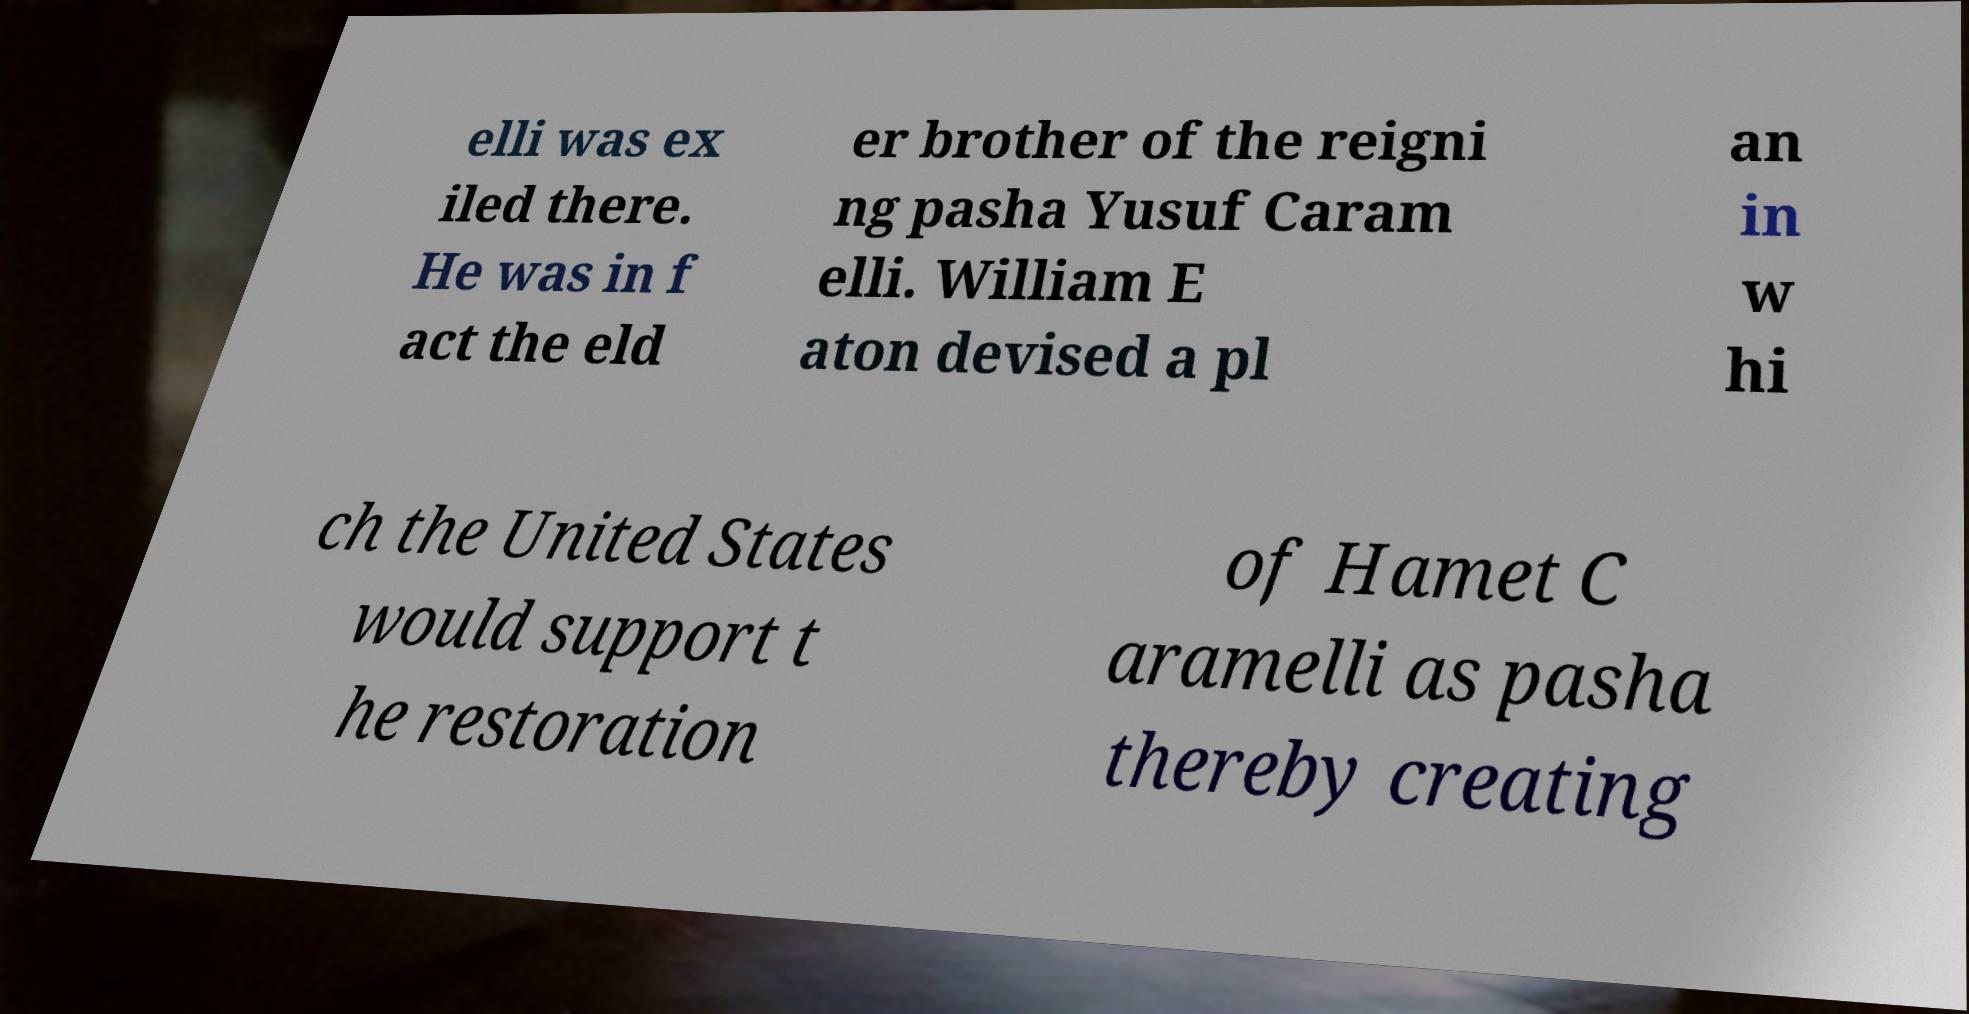Please identify and transcribe the text found in this image. elli was ex iled there. He was in f act the eld er brother of the reigni ng pasha Yusuf Caram elli. William E aton devised a pl an in w hi ch the United States would support t he restoration of Hamet C aramelli as pasha thereby creating 